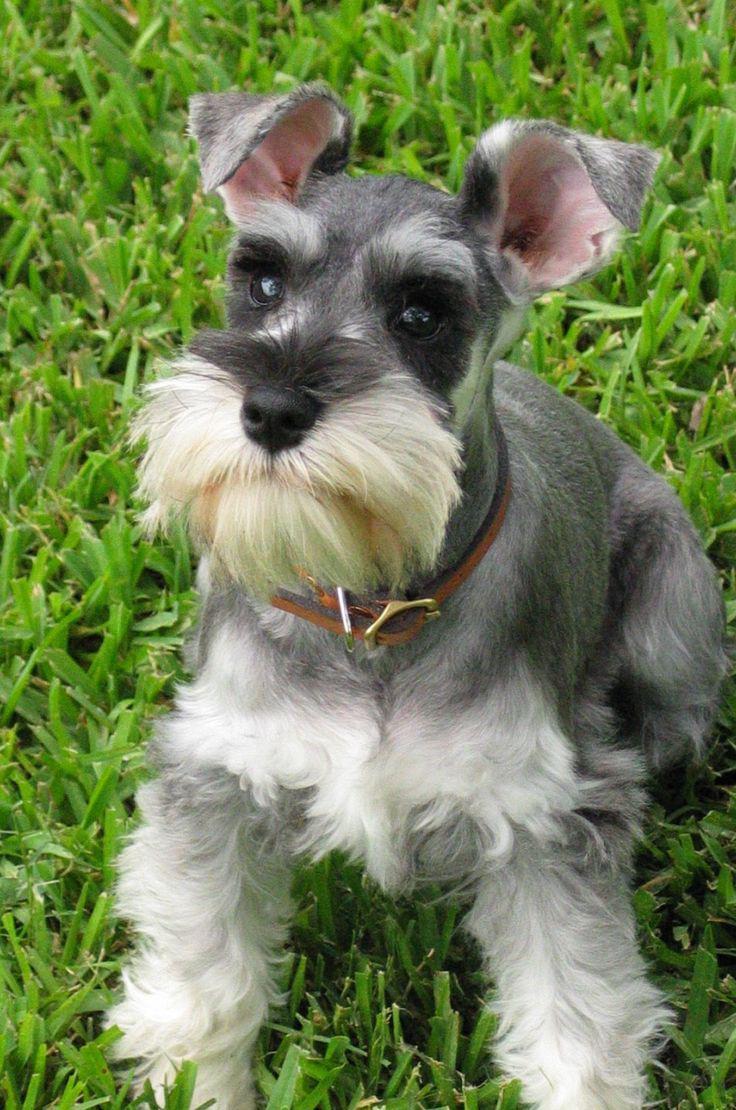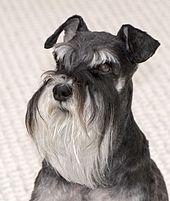The first image is the image on the left, the second image is the image on the right. For the images shown, is this caption "An image shows a schnauzer with bright green foliage." true? Answer yes or no. Yes. 